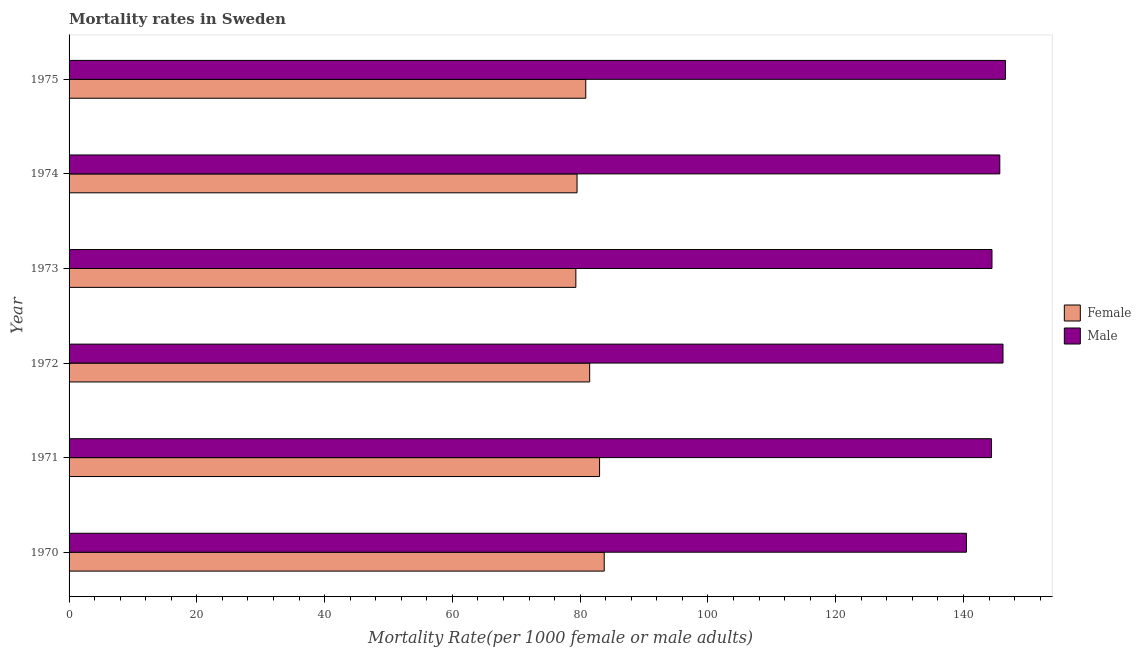Are the number of bars per tick equal to the number of legend labels?
Keep it short and to the point. Yes. How many bars are there on the 1st tick from the top?
Make the answer very short. 2. What is the label of the 2nd group of bars from the top?
Ensure brevity in your answer.  1974. What is the female mortality rate in 1970?
Ensure brevity in your answer.  83.77. Across all years, what is the maximum female mortality rate?
Offer a terse response. 83.77. Across all years, what is the minimum female mortality rate?
Ensure brevity in your answer.  79.33. In which year was the male mortality rate maximum?
Make the answer very short. 1975. What is the total female mortality rate in the graph?
Give a very brief answer. 488.01. What is the difference between the male mortality rate in 1970 and that in 1975?
Provide a short and direct response. -6.11. What is the difference between the male mortality rate in 1971 and the female mortality rate in 1972?
Offer a terse response. 62.9. What is the average male mortality rate per year?
Your answer should be very brief. 144.63. In the year 1975, what is the difference between the male mortality rate and female mortality rate?
Keep it short and to the point. 65.7. In how many years, is the male mortality rate greater than 20 ?
Keep it short and to the point. 6. Is the male mortality rate in 1972 less than that in 1974?
Give a very brief answer. No. Is the difference between the female mortality rate in 1972 and 1973 greater than the difference between the male mortality rate in 1972 and 1973?
Ensure brevity in your answer.  Yes. What is the difference between the highest and the second highest female mortality rate?
Provide a short and direct response. 0.72. What is the difference between the highest and the lowest male mortality rate?
Your response must be concise. 6.11. In how many years, is the female mortality rate greater than the average female mortality rate taken over all years?
Keep it short and to the point. 3. How many bars are there?
Your response must be concise. 12. How many years are there in the graph?
Provide a short and direct response. 6. What is the difference between two consecutive major ticks on the X-axis?
Make the answer very short. 20. Are the values on the major ticks of X-axis written in scientific E-notation?
Keep it short and to the point. No. Does the graph contain any zero values?
Your answer should be compact. No. Does the graph contain grids?
Keep it short and to the point. No. How many legend labels are there?
Offer a terse response. 2. How are the legend labels stacked?
Ensure brevity in your answer.  Vertical. What is the title of the graph?
Provide a short and direct response. Mortality rates in Sweden. Does "Export" appear as one of the legend labels in the graph?
Provide a short and direct response. No. What is the label or title of the X-axis?
Make the answer very short. Mortality Rate(per 1000 female or male adults). What is the label or title of the Y-axis?
Your response must be concise. Year. What is the Mortality Rate(per 1000 female or male adults) in Female in 1970?
Provide a short and direct response. 83.77. What is the Mortality Rate(per 1000 female or male adults) of Male in 1970?
Provide a succinct answer. 140.46. What is the Mortality Rate(per 1000 female or male adults) of Female in 1971?
Offer a terse response. 83.04. What is the Mortality Rate(per 1000 female or male adults) of Male in 1971?
Offer a very short reply. 144.39. What is the Mortality Rate(per 1000 female or male adults) in Female in 1972?
Offer a very short reply. 81.49. What is the Mortality Rate(per 1000 female or male adults) in Male in 1972?
Keep it short and to the point. 146.19. What is the Mortality Rate(per 1000 female or male adults) in Female in 1973?
Offer a terse response. 79.33. What is the Mortality Rate(per 1000 female or male adults) of Male in 1973?
Provide a short and direct response. 144.46. What is the Mortality Rate(per 1000 female or male adults) in Female in 1974?
Provide a succinct answer. 79.51. What is the Mortality Rate(per 1000 female or male adults) of Male in 1974?
Keep it short and to the point. 145.69. What is the Mortality Rate(per 1000 female or male adults) of Female in 1975?
Provide a short and direct response. 80.88. What is the Mortality Rate(per 1000 female or male adults) of Male in 1975?
Offer a very short reply. 146.58. Across all years, what is the maximum Mortality Rate(per 1000 female or male adults) in Female?
Offer a very short reply. 83.77. Across all years, what is the maximum Mortality Rate(per 1000 female or male adults) in Male?
Offer a very short reply. 146.58. Across all years, what is the minimum Mortality Rate(per 1000 female or male adults) in Female?
Offer a very short reply. 79.33. Across all years, what is the minimum Mortality Rate(per 1000 female or male adults) in Male?
Offer a very short reply. 140.46. What is the total Mortality Rate(per 1000 female or male adults) in Female in the graph?
Your answer should be very brief. 488.01. What is the total Mortality Rate(per 1000 female or male adults) in Male in the graph?
Your answer should be compact. 867.77. What is the difference between the Mortality Rate(per 1000 female or male adults) of Female in 1970 and that in 1971?
Ensure brevity in your answer.  0.72. What is the difference between the Mortality Rate(per 1000 female or male adults) of Male in 1970 and that in 1971?
Give a very brief answer. -3.92. What is the difference between the Mortality Rate(per 1000 female or male adults) of Female in 1970 and that in 1972?
Provide a short and direct response. 2.28. What is the difference between the Mortality Rate(per 1000 female or male adults) of Male in 1970 and that in 1972?
Make the answer very short. -5.72. What is the difference between the Mortality Rate(per 1000 female or male adults) of Female in 1970 and that in 1973?
Provide a short and direct response. 4.44. What is the difference between the Mortality Rate(per 1000 female or male adults) in Male in 1970 and that in 1973?
Offer a very short reply. -4. What is the difference between the Mortality Rate(per 1000 female or male adults) in Female in 1970 and that in 1974?
Keep it short and to the point. 4.25. What is the difference between the Mortality Rate(per 1000 female or male adults) in Male in 1970 and that in 1974?
Offer a terse response. -5.22. What is the difference between the Mortality Rate(per 1000 female or male adults) in Female in 1970 and that in 1975?
Provide a succinct answer. 2.89. What is the difference between the Mortality Rate(per 1000 female or male adults) of Male in 1970 and that in 1975?
Offer a terse response. -6.11. What is the difference between the Mortality Rate(per 1000 female or male adults) of Female in 1971 and that in 1972?
Keep it short and to the point. 1.55. What is the difference between the Mortality Rate(per 1000 female or male adults) of Male in 1971 and that in 1972?
Ensure brevity in your answer.  -1.8. What is the difference between the Mortality Rate(per 1000 female or male adults) of Female in 1971 and that in 1973?
Keep it short and to the point. 3.71. What is the difference between the Mortality Rate(per 1000 female or male adults) of Male in 1971 and that in 1973?
Your answer should be very brief. -0.08. What is the difference between the Mortality Rate(per 1000 female or male adults) in Female in 1971 and that in 1974?
Keep it short and to the point. 3.53. What is the difference between the Mortality Rate(per 1000 female or male adults) in Male in 1971 and that in 1974?
Give a very brief answer. -1.3. What is the difference between the Mortality Rate(per 1000 female or male adults) in Female in 1971 and that in 1975?
Your answer should be compact. 2.16. What is the difference between the Mortality Rate(per 1000 female or male adults) of Male in 1971 and that in 1975?
Provide a succinct answer. -2.19. What is the difference between the Mortality Rate(per 1000 female or male adults) in Female in 1972 and that in 1973?
Offer a very short reply. 2.16. What is the difference between the Mortality Rate(per 1000 female or male adults) of Male in 1972 and that in 1973?
Your answer should be very brief. 1.72. What is the difference between the Mortality Rate(per 1000 female or male adults) of Female in 1972 and that in 1974?
Ensure brevity in your answer.  1.98. What is the difference between the Mortality Rate(per 1000 female or male adults) in Male in 1972 and that in 1974?
Provide a short and direct response. 0.5. What is the difference between the Mortality Rate(per 1000 female or male adults) in Female in 1972 and that in 1975?
Give a very brief answer. 0.61. What is the difference between the Mortality Rate(per 1000 female or male adults) of Male in 1972 and that in 1975?
Give a very brief answer. -0.39. What is the difference between the Mortality Rate(per 1000 female or male adults) of Female in 1973 and that in 1974?
Offer a terse response. -0.18. What is the difference between the Mortality Rate(per 1000 female or male adults) of Male in 1973 and that in 1974?
Your response must be concise. -1.22. What is the difference between the Mortality Rate(per 1000 female or male adults) of Female in 1973 and that in 1975?
Give a very brief answer. -1.55. What is the difference between the Mortality Rate(per 1000 female or male adults) of Male in 1973 and that in 1975?
Provide a short and direct response. -2.11. What is the difference between the Mortality Rate(per 1000 female or male adults) in Female in 1974 and that in 1975?
Your answer should be very brief. -1.37. What is the difference between the Mortality Rate(per 1000 female or male adults) in Male in 1974 and that in 1975?
Make the answer very short. -0.89. What is the difference between the Mortality Rate(per 1000 female or male adults) of Female in 1970 and the Mortality Rate(per 1000 female or male adults) of Male in 1971?
Your answer should be compact. -60.62. What is the difference between the Mortality Rate(per 1000 female or male adults) in Female in 1970 and the Mortality Rate(per 1000 female or male adults) in Male in 1972?
Keep it short and to the point. -62.42. What is the difference between the Mortality Rate(per 1000 female or male adults) of Female in 1970 and the Mortality Rate(per 1000 female or male adults) of Male in 1973?
Your answer should be compact. -60.7. What is the difference between the Mortality Rate(per 1000 female or male adults) in Female in 1970 and the Mortality Rate(per 1000 female or male adults) in Male in 1974?
Ensure brevity in your answer.  -61.92. What is the difference between the Mortality Rate(per 1000 female or male adults) of Female in 1970 and the Mortality Rate(per 1000 female or male adults) of Male in 1975?
Your response must be concise. -62.81. What is the difference between the Mortality Rate(per 1000 female or male adults) in Female in 1971 and the Mortality Rate(per 1000 female or male adults) in Male in 1972?
Offer a very short reply. -63.15. What is the difference between the Mortality Rate(per 1000 female or male adults) of Female in 1971 and the Mortality Rate(per 1000 female or male adults) of Male in 1973?
Offer a terse response. -61.42. What is the difference between the Mortality Rate(per 1000 female or male adults) in Female in 1971 and the Mortality Rate(per 1000 female or male adults) in Male in 1974?
Your answer should be very brief. -62.65. What is the difference between the Mortality Rate(per 1000 female or male adults) in Female in 1971 and the Mortality Rate(per 1000 female or male adults) in Male in 1975?
Your response must be concise. -63.53. What is the difference between the Mortality Rate(per 1000 female or male adults) in Female in 1972 and the Mortality Rate(per 1000 female or male adults) in Male in 1973?
Offer a terse response. -62.98. What is the difference between the Mortality Rate(per 1000 female or male adults) in Female in 1972 and the Mortality Rate(per 1000 female or male adults) in Male in 1974?
Provide a short and direct response. -64.2. What is the difference between the Mortality Rate(per 1000 female or male adults) in Female in 1972 and the Mortality Rate(per 1000 female or male adults) in Male in 1975?
Keep it short and to the point. -65.09. What is the difference between the Mortality Rate(per 1000 female or male adults) of Female in 1973 and the Mortality Rate(per 1000 female or male adults) of Male in 1974?
Keep it short and to the point. -66.36. What is the difference between the Mortality Rate(per 1000 female or male adults) in Female in 1973 and the Mortality Rate(per 1000 female or male adults) in Male in 1975?
Your response must be concise. -67.25. What is the difference between the Mortality Rate(per 1000 female or male adults) in Female in 1974 and the Mortality Rate(per 1000 female or male adults) in Male in 1975?
Your answer should be compact. -67.06. What is the average Mortality Rate(per 1000 female or male adults) of Female per year?
Offer a very short reply. 81.34. What is the average Mortality Rate(per 1000 female or male adults) in Male per year?
Ensure brevity in your answer.  144.63. In the year 1970, what is the difference between the Mortality Rate(per 1000 female or male adults) of Female and Mortality Rate(per 1000 female or male adults) of Male?
Provide a short and direct response. -56.7. In the year 1971, what is the difference between the Mortality Rate(per 1000 female or male adults) of Female and Mortality Rate(per 1000 female or male adults) of Male?
Provide a succinct answer. -61.35. In the year 1972, what is the difference between the Mortality Rate(per 1000 female or male adults) in Female and Mortality Rate(per 1000 female or male adults) in Male?
Your answer should be compact. -64.7. In the year 1973, what is the difference between the Mortality Rate(per 1000 female or male adults) in Female and Mortality Rate(per 1000 female or male adults) in Male?
Provide a succinct answer. -65.14. In the year 1974, what is the difference between the Mortality Rate(per 1000 female or male adults) of Female and Mortality Rate(per 1000 female or male adults) of Male?
Make the answer very short. -66.17. In the year 1975, what is the difference between the Mortality Rate(per 1000 female or male adults) of Female and Mortality Rate(per 1000 female or male adults) of Male?
Your answer should be compact. -65.7. What is the ratio of the Mortality Rate(per 1000 female or male adults) of Female in 1970 to that in 1971?
Provide a short and direct response. 1.01. What is the ratio of the Mortality Rate(per 1000 female or male adults) of Male in 1970 to that in 1971?
Provide a short and direct response. 0.97. What is the ratio of the Mortality Rate(per 1000 female or male adults) of Female in 1970 to that in 1972?
Your answer should be very brief. 1.03. What is the ratio of the Mortality Rate(per 1000 female or male adults) in Male in 1970 to that in 1972?
Ensure brevity in your answer.  0.96. What is the ratio of the Mortality Rate(per 1000 female or male adults) in Female in 1970 to that in 1973?
Offer a terse response. 1.06. What is the ratio of the Mortality Rate(per 1000 female or male adults) of Male in 1970 to that in 1973?
Provide a short and direct response. 0.97. What is the ratio of the Mortality Rate(per 1000 female or male adults) in Female in 1970 to that in 1974?
Offer a very short reply. 1.05. What is the ratio of the Mortality Rate(per 1000 female or male adults) in Male in 1970 to that in 1974?
Your response must be concise. 0.96. What is the ratio of the Mortality Rate(per 1000 female or male adults) in Female in 1970 to that in 1975?
Ensure brevity in your answer.  1.04. What is the ratio of the Mortality Rate(per 1000 female or male adults) of Female in 1971 to that in 1972?
Give a very brief answer. 1.02. What is the ratio of the Mortality Rate(per 1000 female or male adults) of Male in 1971 to that in 1972?
Make the answer very short. 0.99. What is the ratio of the Mortality Rate(per 1000 female or male adults) of Female in 1971 to that in 1973?
Provide a short and direct response. 1.05. What is the ratio of the Mortality Rate(per 1000 female or male adults) of Male in 1971 to that in 1973?
Provide a short and direct response. 1. What is the ratio of the Mortality Rate(per 1000 female or male adults) in Female in 1971 to that in 1974?
Offer a terse response. 1.04. What is the ratio of the Mortality Rate(per 1000 female or male adults) of Male in 1971 to that in 1974?
Give a very brief answer. 0.99. What is the ratio of the Mortality Rate(per 1000 female or male adults) of Female in 1971 to that in 1975?
Your response must be concise. 1.03. What is the ratio of the Mortality Rate(per 1000 female or male adults) of Male in 1971 to that in 1975?
Offer a terse response. 0.99. What is the ratio of the Mortality Rate(per 1000 female or male adults) in Female in 1972 to that in 1973?
Offer a terse response. 1.03. What is the ratio of the Mortality Rate(per 1000 female or male adults) in Male in 1972 to that in 1973?
Your response must be concise. 1.01. What is the ratio of the Mortality Rate(per 1000 female or male adults) in Female in 1972 to that in 1974?
Provide a succinct answer. 1.02. What is the ratio of the Mortality Rate(per 1000 female or male adults) in Female in 1972 to that in 1975?
Offer a terse response. 1.01. What is the ratio of the Mortality Rate(per 1000 female or male adults) of Female in 1973 to that in 1974?
Give a very brief answer. 1. What is the ratio of the Mortality Rate(per 1000 female or male adults) in Male in 1973 to that in 1974?
Offer a terse response. 0.99. What is the ratio of the Mortality Rate(per 1000 female or male adults) of Female in 1973 to that in 1975?
Your response must be concise. 0.98. What is the ratio of the Mortality Rate(per 1000 female or male adults) in Male in 1973 to that in 1975?
Your response must be concise. 0.99. What is the ratio of the Mortality Rate(per 1000 female or male adults) of Female in 1974 to that in 1975?
Provide a succinct answer. 0.98. What is the ratio of the Mortality Rate(per 1000 female or male adults) in Male in 1974 to that in 1975?
Offer a terse response. 0.99. What is the difference between the highest and the second highest Mortality Rate(per 1000 female or male adults) in Female?
Your answer should be compact. 0.72. What is the difference between the highest and the second highest Mortality Rate(per 1000 female or male adults) of Male?
Offer a terse response. 0.39. What is the difference between the highest and the lowest Mortality Rate(per 1000 female or male adults) in Female?
Offer a very short reply. 4.44. What is the difference between the highest and the lowest Mortality Rate(per 1000 female or male adults) of Male?
Give a very brief answer. 6.11. 